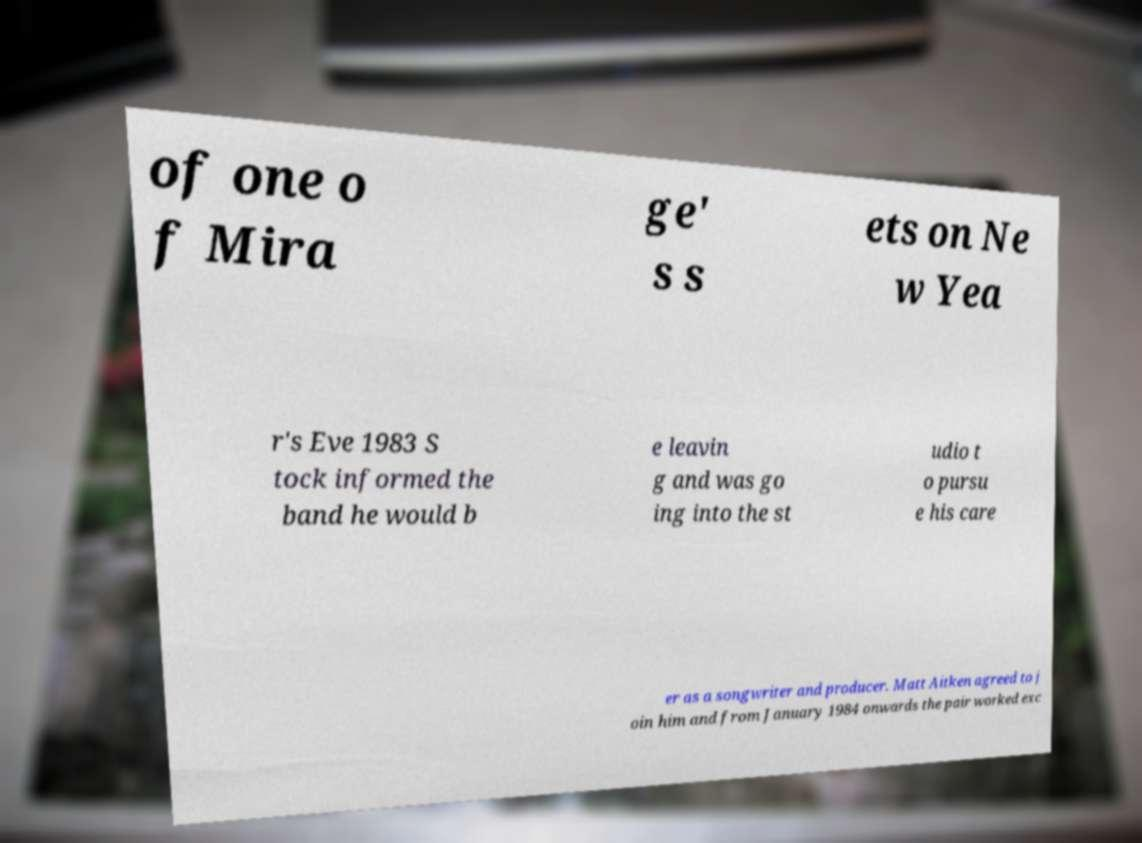Please identify and transcribe the text found in this image. of one o f Mira ge' s s ets on Ne w Yea r's Eve 1983 S tock informed the band he would b e leavin g and was go ing into the st udio t o pursu e his care er as a songwriter and producer. Matt Aitken agreed to j oin him and from January 1984 onwards the pair worked exc 